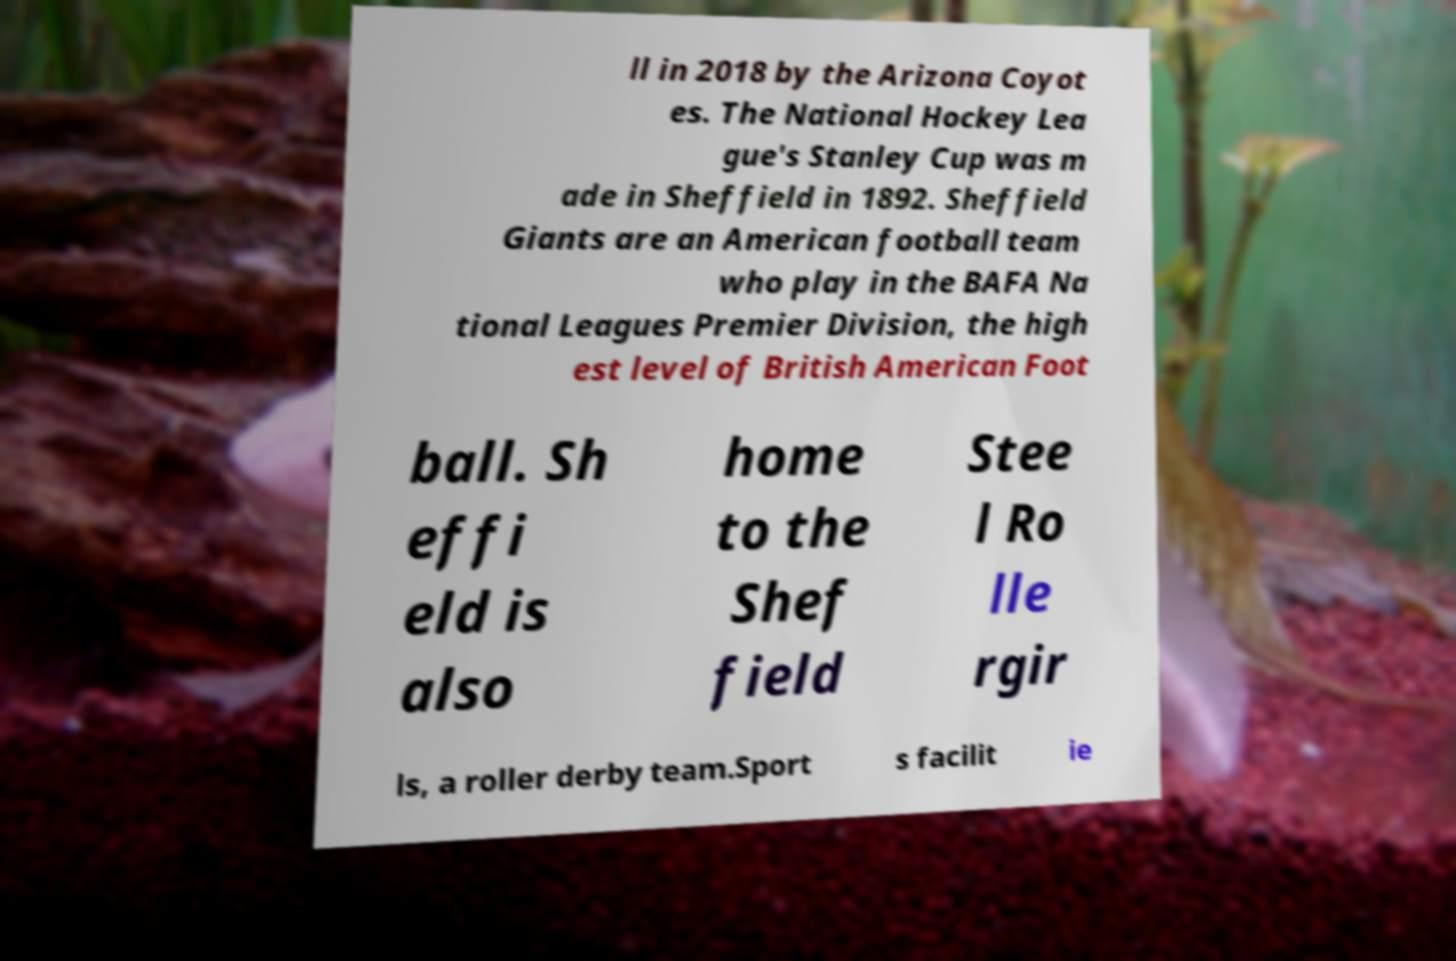Could you extract and type out the text from this image? ll in 2018 by the Arizona Coyot es. The National Hockey Lea gue's Stanley Cup was m ade in Sheffield in 1892. Sheffield Giants are an American football team who play in the BAFA Na tional Leagues Premier Division, the high est level of British American Foot ball. Sh effi eld is also home to the Shef field Stee l Ro lle rgir ls, a roller derby team.Sport s facilit ie 